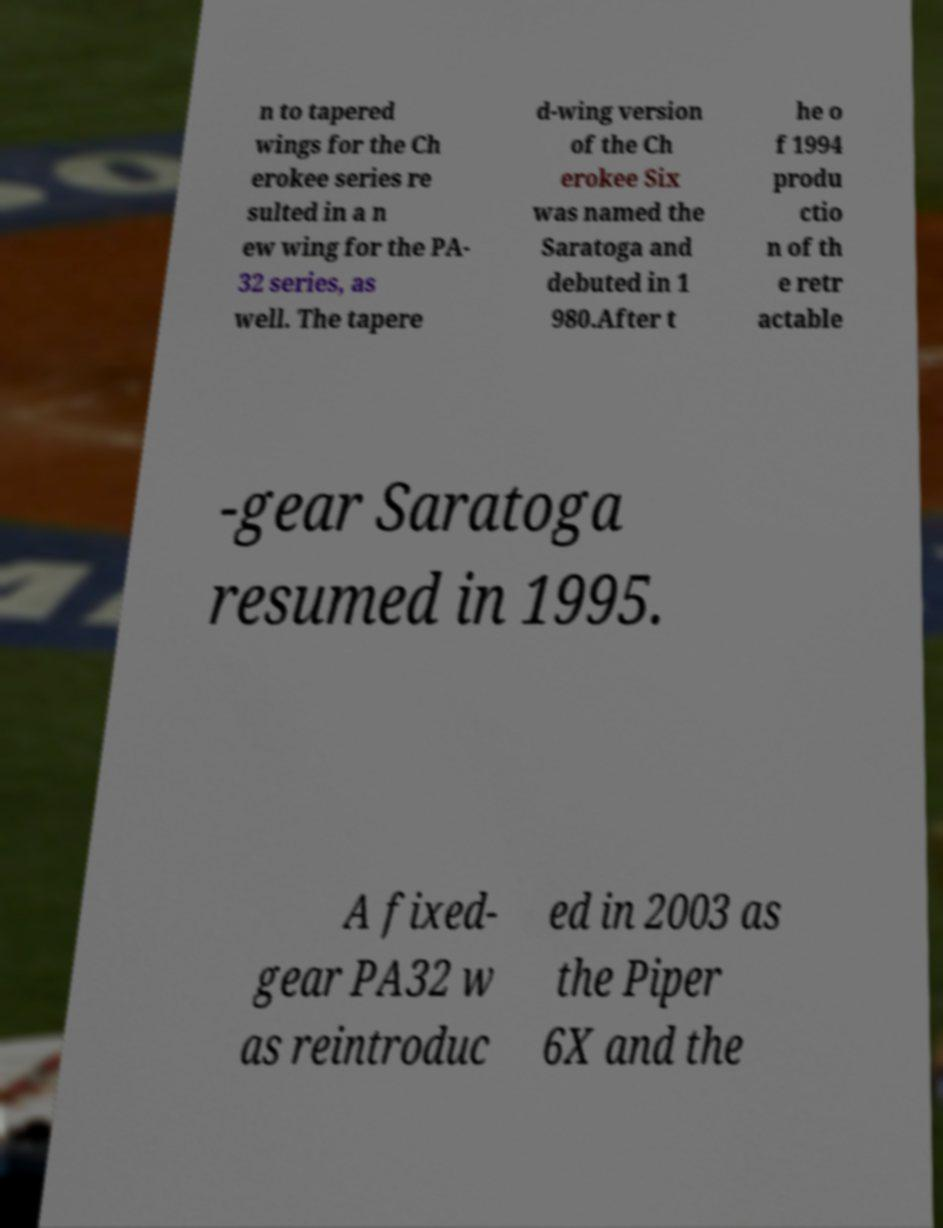Please read and relay the text visible in this image. What does it say? n to tapered wings for the Ch erokee series re sulted in a n ew wing for the PA- 32 series, as well. The tapere d-wing version of the Ch erokee Six was named the Saratoga and debuted in 1 980.After t he o f 1994 produ ctio n of th e retr actable -gear Saratoga resumed in 1995. A fixed- gear PA32 w as reintroduc ed in 2003 as the Piper 6X and the 